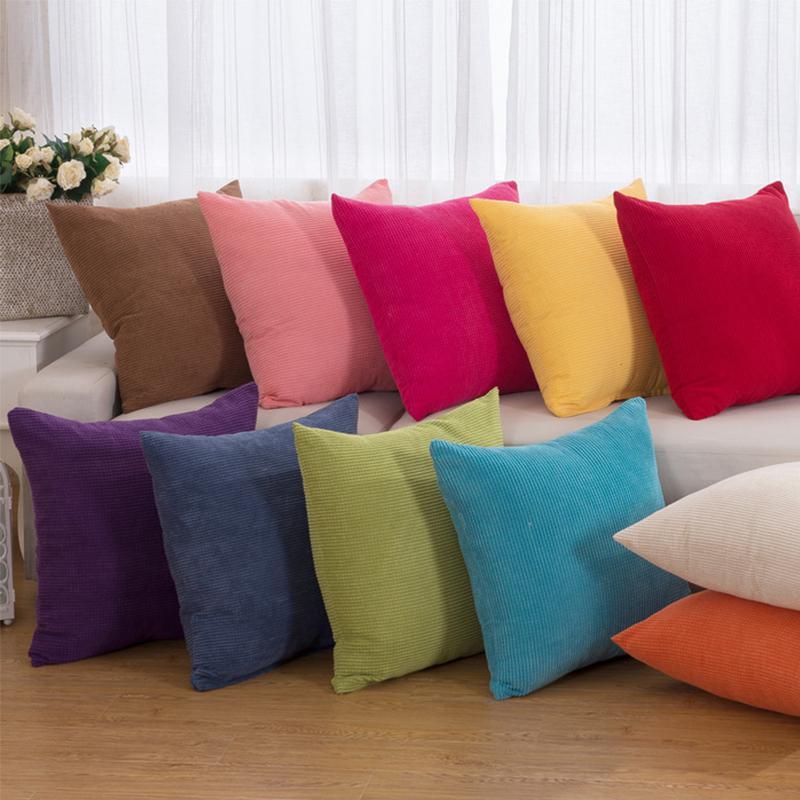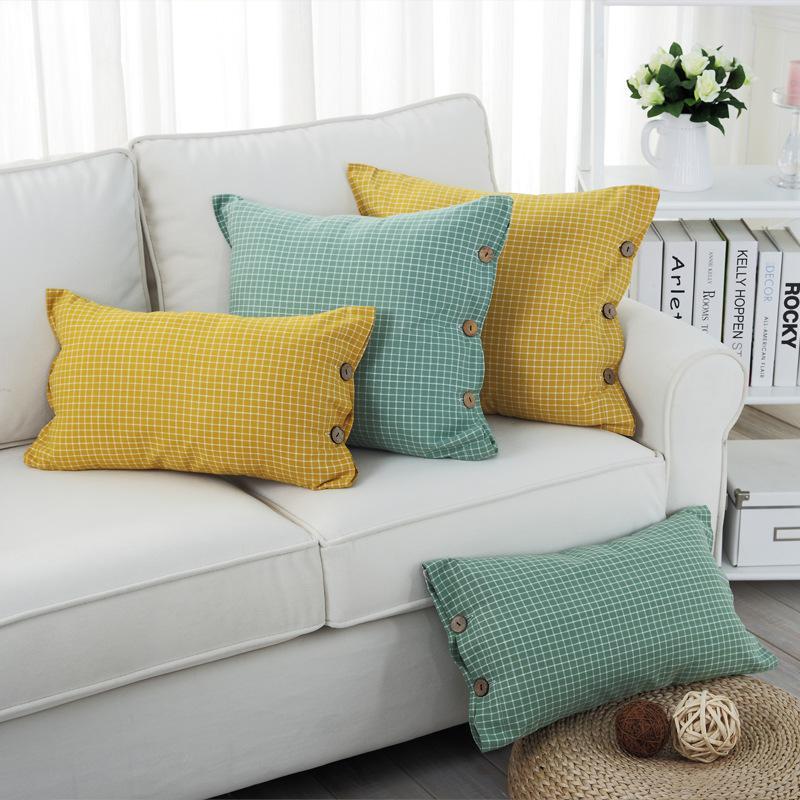The first image is the image on the left, the second image is the image on the right. Given the left and right images, does the statement "Two different colored pillows are stacked horizontally on a floor beside no more than two other different colored pillows." hold true? Answer yes or no. No. The first image is the image on the left, the second image is the image on the right. Analyze the images presented: Is the assertion "One image features at least one pillow with button closures, and the other image contains at least 7 square pillows of different colors." valid? Answer yes or no. Yes. 